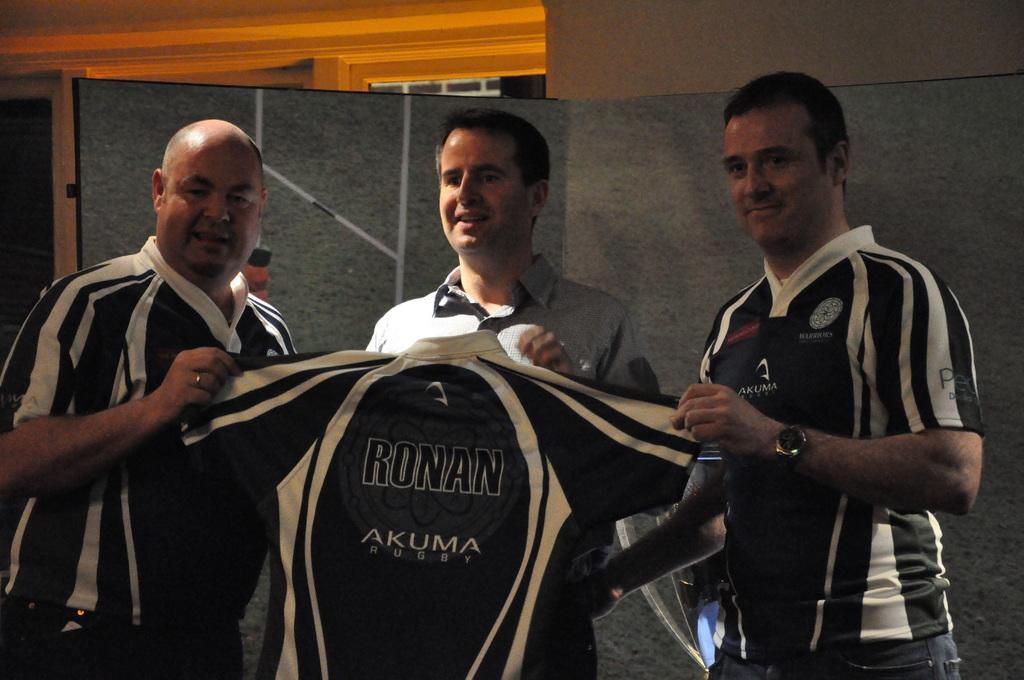<image>
Render a clear and concise summary of the photo. Three men holding a jersey with the word Akuma on it. 